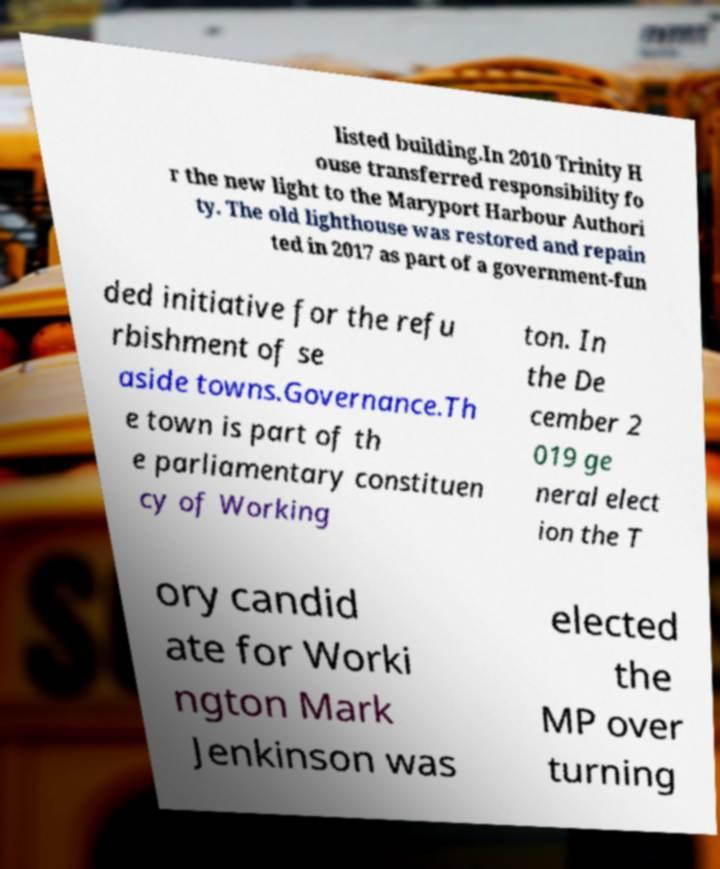Please identify and transcribe the text found in this image. listed building.In 2010 Trinity H ouse transferred responsibility fo r the new light to the Maryport Harbour Authori ty. The old lighthouse was restored and repain ted in 2017 as part of a government-fun ded initiative for the refu rbishment of se aside towns.Governance.Th e town is part of th e parliamentary constituen cy of Working ton. In the De cember 2 019 ge neral elect ion the T ory candid ate for Worki ngton Mark Jenkinson was elected the MP over turning 